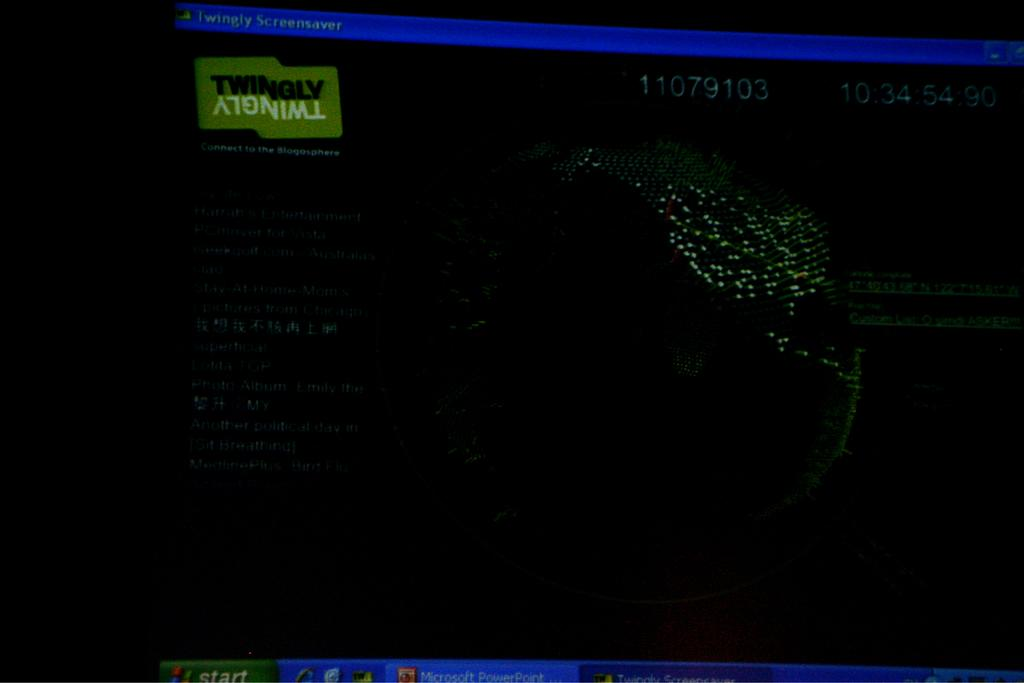Provide a one-sentence caption for the provided image. a dark computer screen with the word twingly at the top right corner. 